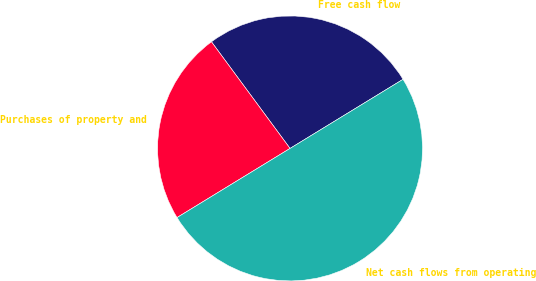Convert chart to OTSL. <chart><loc_0><loc_0><loc_500><loc_500><pie_chart><fcel>Free cash flow<fcel>Purchases of property and<fcel>Net cash flows from operating<nl><fcel>26.37%<fcel>23.63%<fcel>50.0%<nl></chart> 